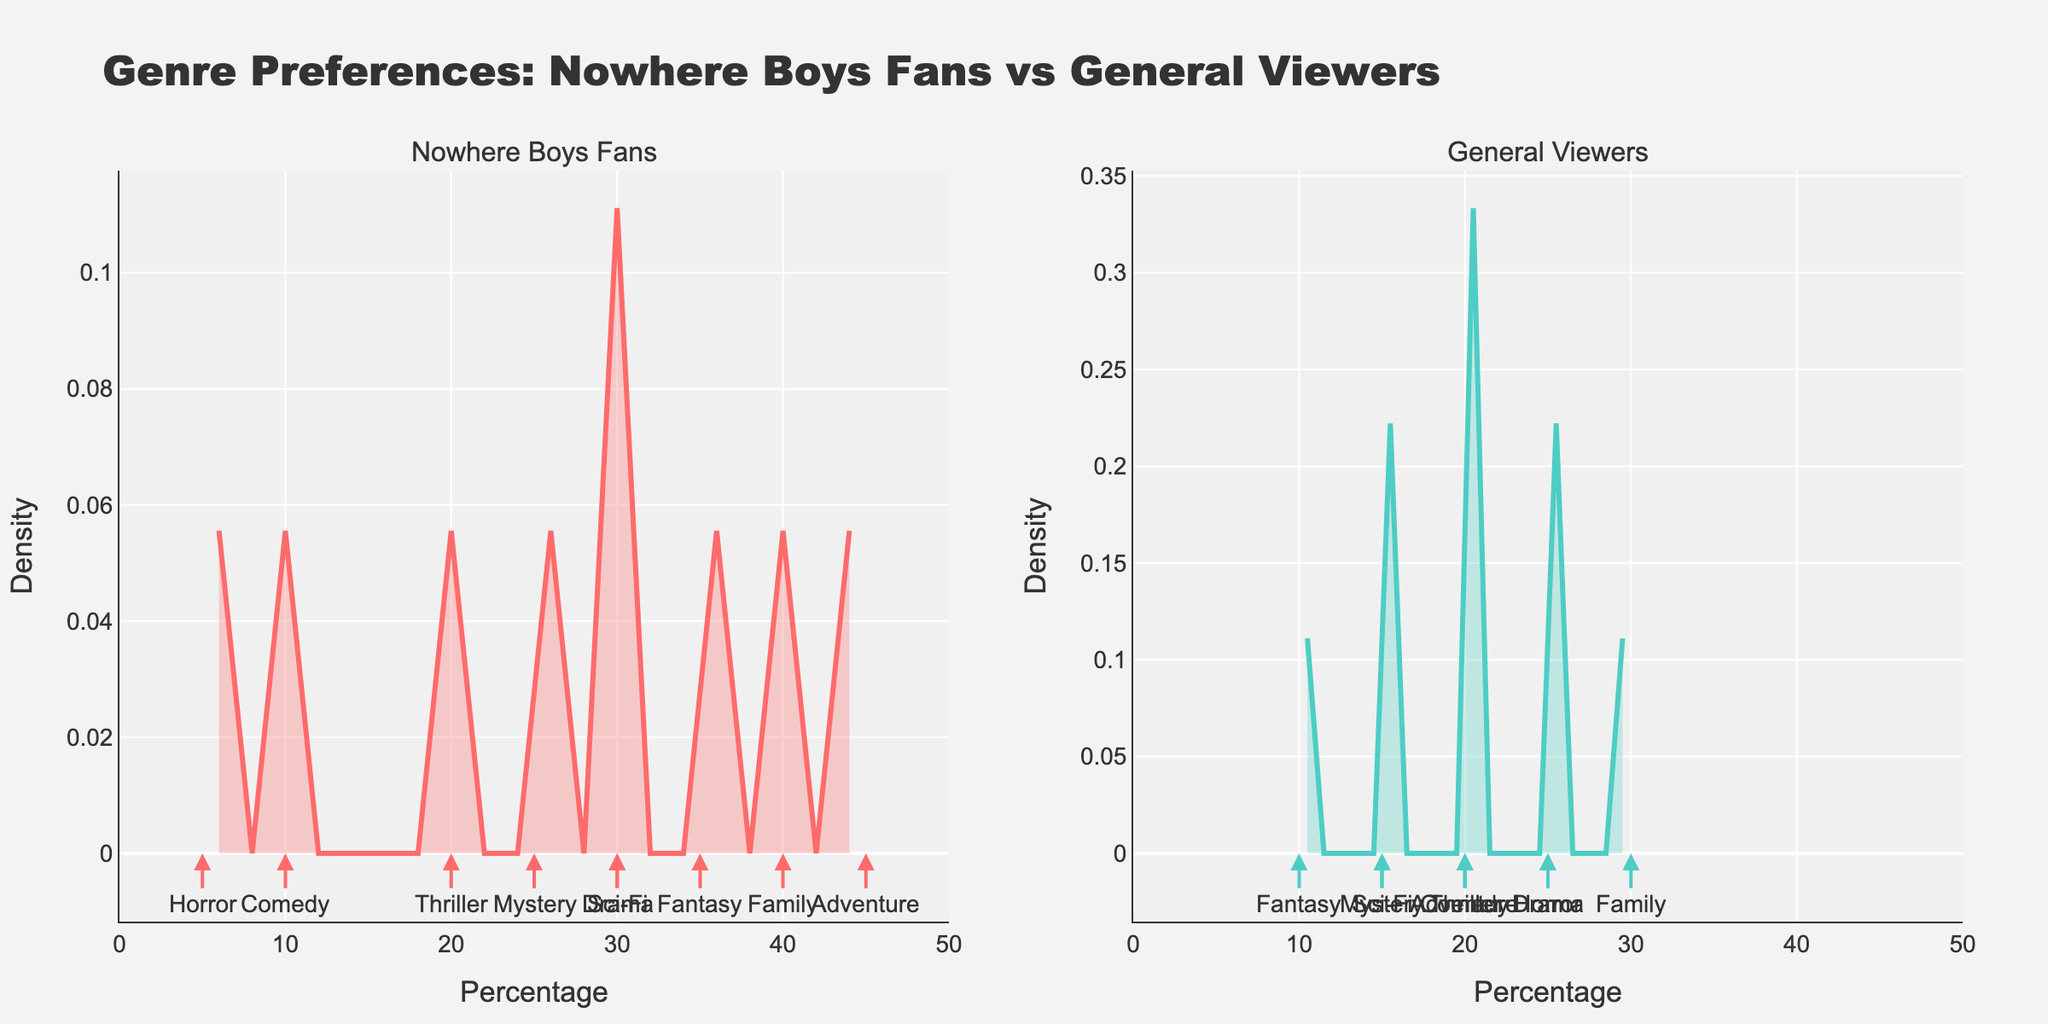Which subplot has the higher peak density? The peak density represents the genre preference concentration. By visually comparing the peaks of the density plots in both subplots, the subplot for Nowhere Boys Fans has a higher peak.
Answer: Nowhere Boys Fans What is the title of the figure? The title is usually placed at the top of the plot and provides a summary or insight into what the figure represents.
Answer: Genre Preferences: Nowhere Boys Fans vs General Viewers Which genre appears with the highest percentage among Nowhere Boys fans? By examining the annotations within the Nowhere Boys Fans subplot, the highest percentage is associated with Adventure at 45%.
Answer: Adventure Which genres have a higher percentage among general TV show viewers than among Nowhere Boys fans? To determine this, compare the percentages of each genre in the general viewers subplot to those in the Nowhere Boys Fans subplot. Horror, Comedy, and Thriller have higher percentages among general TV show viewers.
Answer: Horror, Comedy, Thriller What is the common genre preferred equally by both groups? By looking at the annotations and comparing percentages in both subplots, Thriller has a 20% preference in both Nowhere Boys Fans and general TV show viewers.
Answer: Thriller Which genre has the largest disparity in preference percentages between the two groups? Calculate the absolute difference in percentages for each genre between the two groups. Fantasy has a 25 percentage point difference (35% for Nowhere Boys Fans vs 10% for general viewers).
Answer: Fantasy What percentage of Nowhere Boys fans prefer Family genre? Look at the annotation for Family in the Nowhere Boys Fans subplot to see the percentage.
Answer: 40% Are Sci-Fi preferences closer among Nowhere Boys fans or general TV show viewers? Compare the densities for the Sci-Fi annotation in both subplots. Sci-Fi has 30% for Nowhere Boys Fans and 15% for general viewers, showing closer preference among Nowhere Boys fans.
Answer: Nowhere Boys fans Which genre is least preferred by Nowhere Boys fans? Identify the genre annotation with the lowest percentage in the Nowhere Boys Fans subplot, which is Horror with 5%.
Answer: Horror What's the average percentage of Adventure and Drama genres preference among general viewers? Add the percentages for Adventure (20%) and Drama (25%) and divide by 2.
Answer: (20%+25%)/2 = 22.5% 